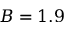Convert formula to latex. <formula><loc_0><loc_0><loc_500><loc_500>B = 1 . 9</formula> 